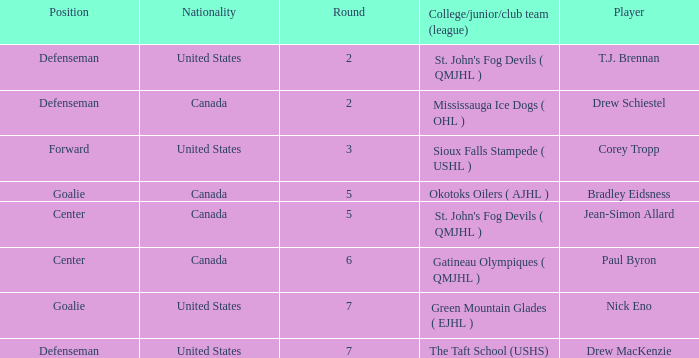What is the nationality of the goalie in Round 7? United States. 